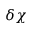<formula> <loc_0><loc_0><loc_500><loc_500>\delta \chi</formula> 